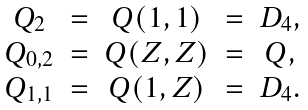<formula> <loc_0><loc_0><loc_500><loc_500>\begin{matrix} Q _ { 2 } & = & Q ( 1 , 1 ) & = & D _ { 4 } , \\ Q _ { 0 , 2 } & = & Q ( Z , Z ) & = & Q , \\ Q _ { 1 , 1 } & = & Q ( 1 , Z ) & = & D _ { 4 } . \end{matrix}</formula> 